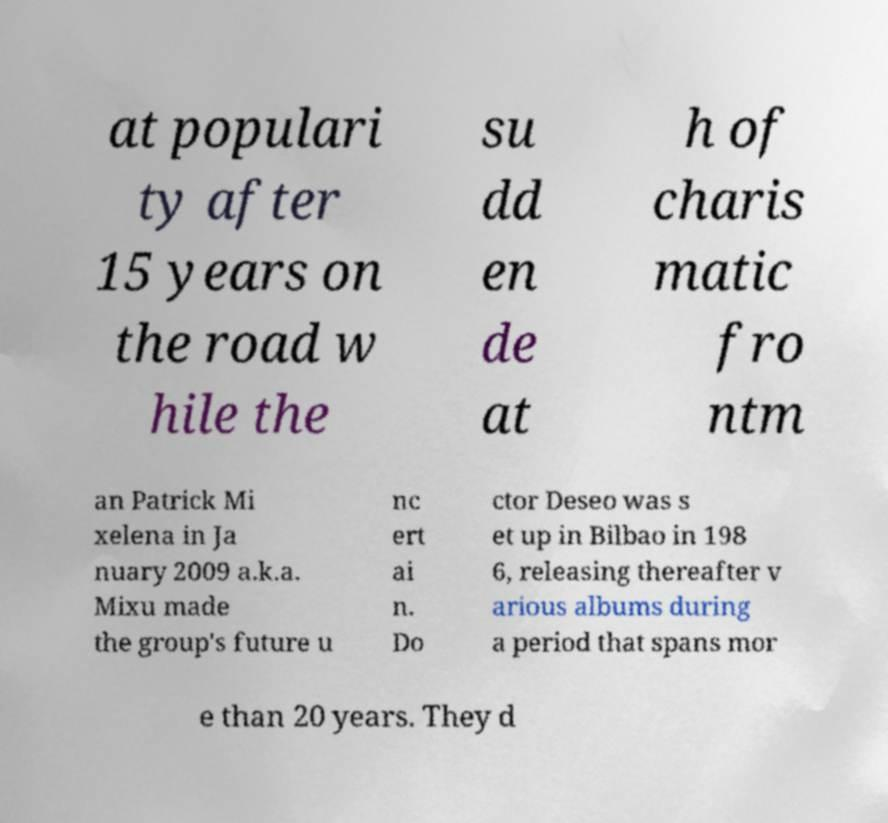For documentation purposes, I need the text within this image transcribed. Could you provide that? at populari ty after 15 years on the road w hile the su dd en de at h of charis matic fro ntm an Patrick Mi xelena in Ja nuary 2009 a.k.a. Mixu made the group's future u nc ert ai n. Do ctor Deseo was s et up in Bilbao in 198 6, releasing thereafter v arious albums during a period that spans mor e than 20 years. They d 